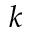Convert formula to latex. <formula><loc_0><loc_0><loc_500><loc_500>k</formula> 